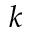Convert formula to latex. <formula><loc_0><loc_0><loc_500><loc_500>k</formula> 